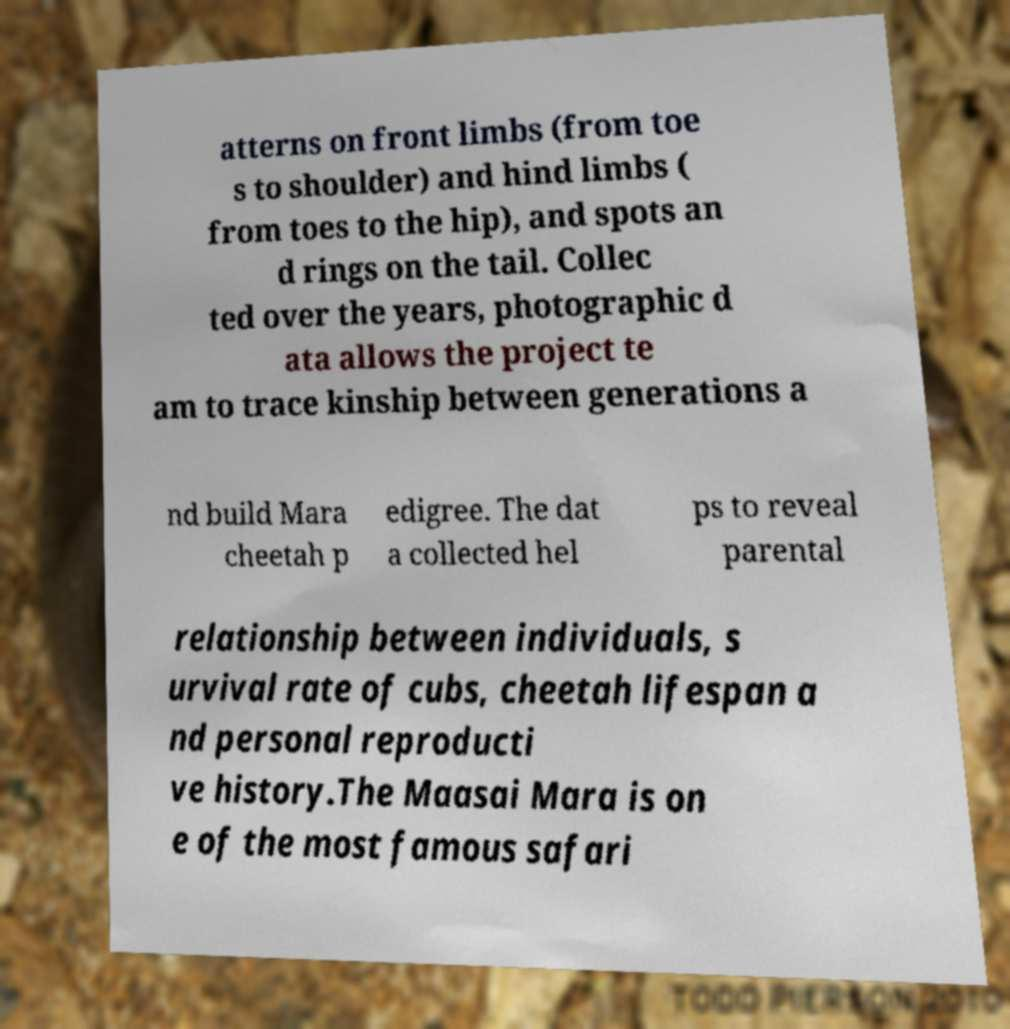Can you accurately transcribe the text from the provided image for me? atterns on front limbs (from toe s to shoulder) and hind limbs ( from toes to the hip), and spots an d rings on the tail. Collec ted over the years, photographic d ata allows the project te am to trace kinship between generations a nd build Mara cheetah p edigree. The dat a collected hel ps to reveal parental relationship between individuals, s urvival rate of cubs, cheetah lifespan a nd personal reproducti ve history.The Maasai Mara is on e of the most famous safari 